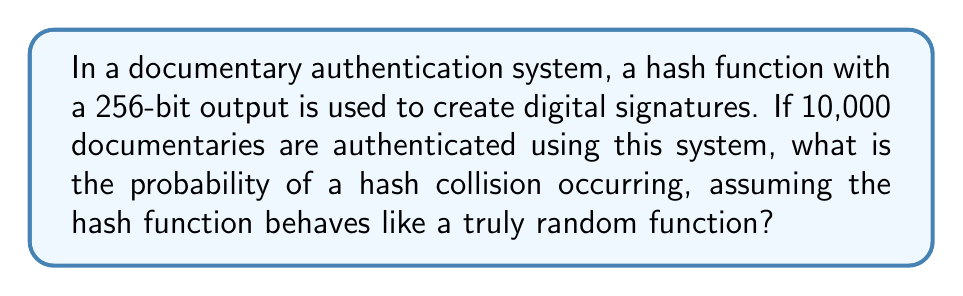Can you solve this math problem? To solve this problem, we'll use the birthday paradox approach, which is applicable to hash collision probabilities:

1. The hash function has a 256-bit output, so the total number of possible hash values is:
   $n = 2^{256}$

2. The number of documentaries being authenticated is:
   $k = 10,000$

3. The probability of no collision occurring is given by:
   $$P(\text{no collision}) = \frac{n!}{n^k(n-k)!}$$

4. For large $n$ and relatively small $k$, we can approximate this using the exponential function:
   $$P(\text{no collision}) \approx e^{-\frac{k(k-1)}{2n}}$$

5. Substituting our values:
   $$P(\text{no collision}) \approx e^{-\frac{10000(9999)}{2 \cdot 2^{256}}}$$

6. Simplify:
   $$P(\text{no collision}) \approx e^{-\frac{99990000}{2^{257}}}$$

7. The probability of a collision is the complement of no collision:
   $$P(\text{collision}) = 1 - P(\text{no collision})$$
   $$P(\text{collision}) = 1 - e^{-\frac{99990000}{2^{257}}}$$

8. Calculate the result:
   $$P(\text{collision}) \approx 1.18 \times 10^{-67}$$

This extremely low probability demonstrates the robustness of 256-bit hash functions for digital signatures in documentary authentication systems.
Answer: $1.18 \times 10^{-67}$ 